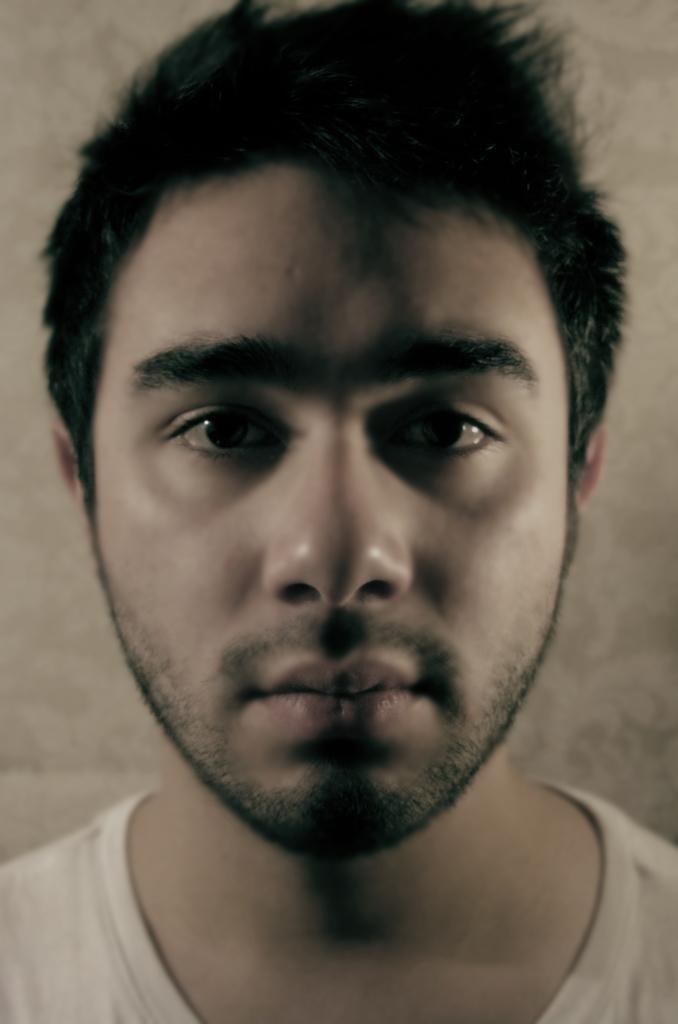Could you give a brief overview of what you see in this image? In this picture there is a person. In the background it is well. 